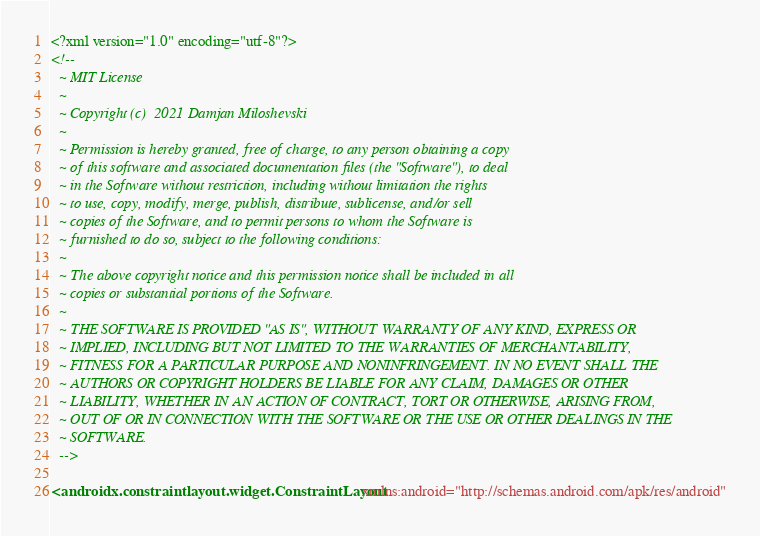<code> <loc_0><loc_0><loc_500><loc_500><_XML_><?xml version="1.0" encoding="utf-8"?>
<!--
  ~ MIT License
  ~
  ~ Copyright (c)  2021 Damjan Miloshevski
  ~
  ~ Permission is hereby granted, free of charge, to any person obtaining a copy
  ~ of this software and associated documentation files (the "Software"), to deal
  ~ in the Software without restriction, including without limitation the rights
  ~ to use, copy, modify, merge, publish, distribute, sublicense, and/or sell
  ~ copies of the Software, and to permit persons to whom the Software is
  ~ furnished to do so, subject to the following conditions:
  ~
  ~ The above copyright notice and this permission notice shall be included in all
  ~ copies or substantial portions of the Software.
  ~
  ~ THE SOFTWARE IS PROVIDED "AS IS", WITHOUT WARRANTY OF ANY KIND, EXPRESS OR
  ~ IMPLIED, INCLUDING BUT NOT LIMITED TO THE WARRANTIES OF MERCHANTABILITY,
  ~ FITNESS FOR A PARTICULAR PURPOSE AND NONINFRINGEMENT. IN NO EVENT SHALL THE
  ~ AUTHORS OR COPYRIGHT HOLDERS BE LIABLE FOR ANY CLAIM, DAMAGES OR OTHER
  ~ LIABILITY, WHETHER IN AN ACTION OF CONTRACT, TORT OR OTHERWISE, ARISING FROM,
  ~ OUT OF OR IN CONNECTION WITH THE SOFTWARE OR THE USE OR OTHER DEALINGS IN THE
  ~ SOFTWARE.
  -->

<androidx.constraintlayout.widget.ConstraintLayout xmlns:android="http://schemas.android.com/apk/res/android"</code> 